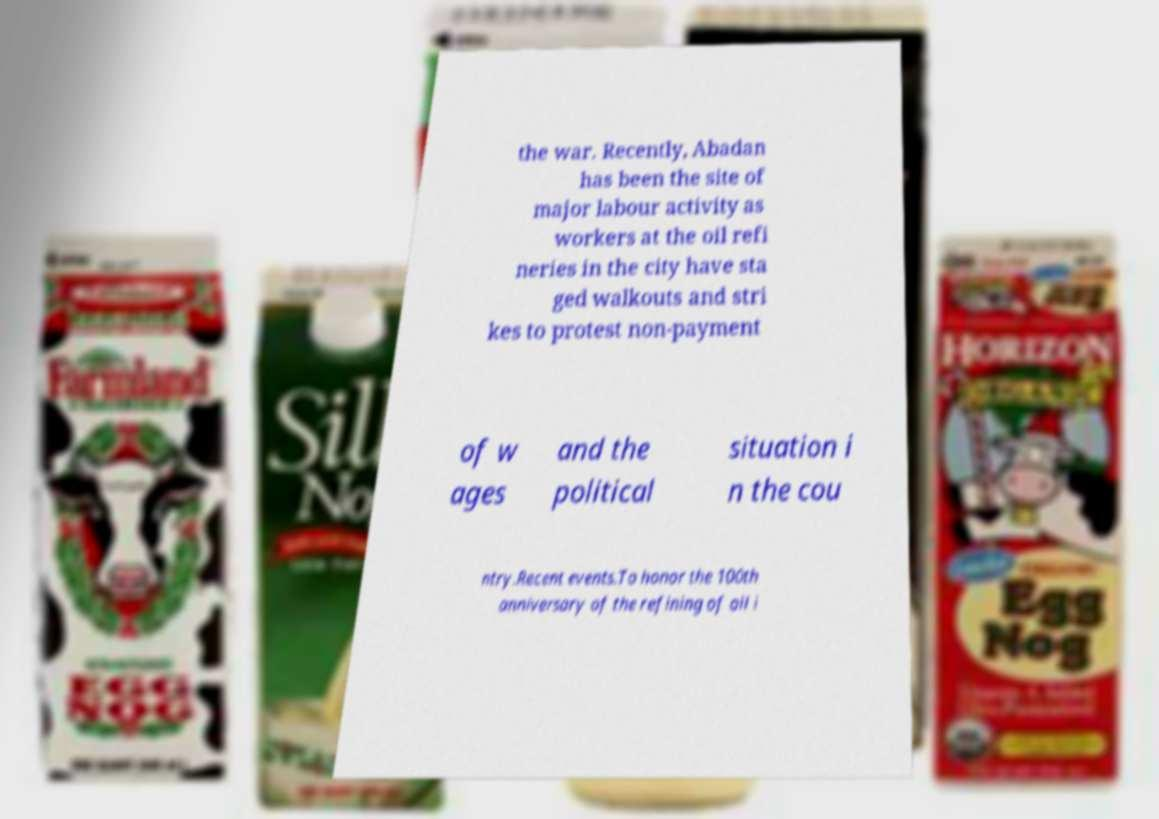I need the written content from this picture converted into text. Can you do that? the war. Recently, Abadan has been the site of major labour activity as workers at the oil refi neries in the city have sta ged walkouts and stri kes to protest non-payment of w ages and the political situation i n the cou ntry.Recent events.To honor the 100th anniversary of the refining of oil i 